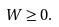<formula> <loc_0><loc_0><loc_500><loc_500>W \geq 0 .</formula> 